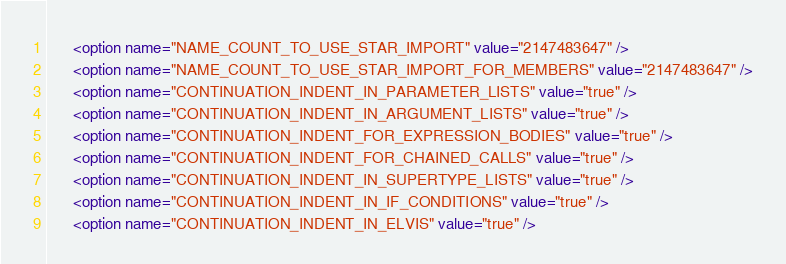<code> <loc_0><loc_0><loc_500><loc_500><_XML_>      <option name="NAME_COUNT_TO_USE_STAR_IMPORT" value="2147483647" />
      <option name="NAME_COUNT_TO_USE_STAR_IMPORT_FOR_MEMBERS" value="2147483647" />
      <option name="CONTINUATION_INDENT_IN_PARAMETER_LISTS" value="true" />
      <option name="CONTINUATION_INDENT_IN_ARGUMENT_LISTS" value="true" />
      <option name="CONTINUATION_INDENT_FOR_EXPRESSION_BODIES" value="true" />
      <option name="CONTINUATION_INDENT_FOR_CHAINED_CALLS" value="true" />
      <option name="CONTINUATION_INDENT_IN_SUPERTYPE_LISTS" value="true" />
      <option name="CONTINUATION_INDENT_IN_IF_CONDITIONS" value="true" />
      <option name="CONTINUATION_INDENT_IN_ELVIS" value="true" /></code> 